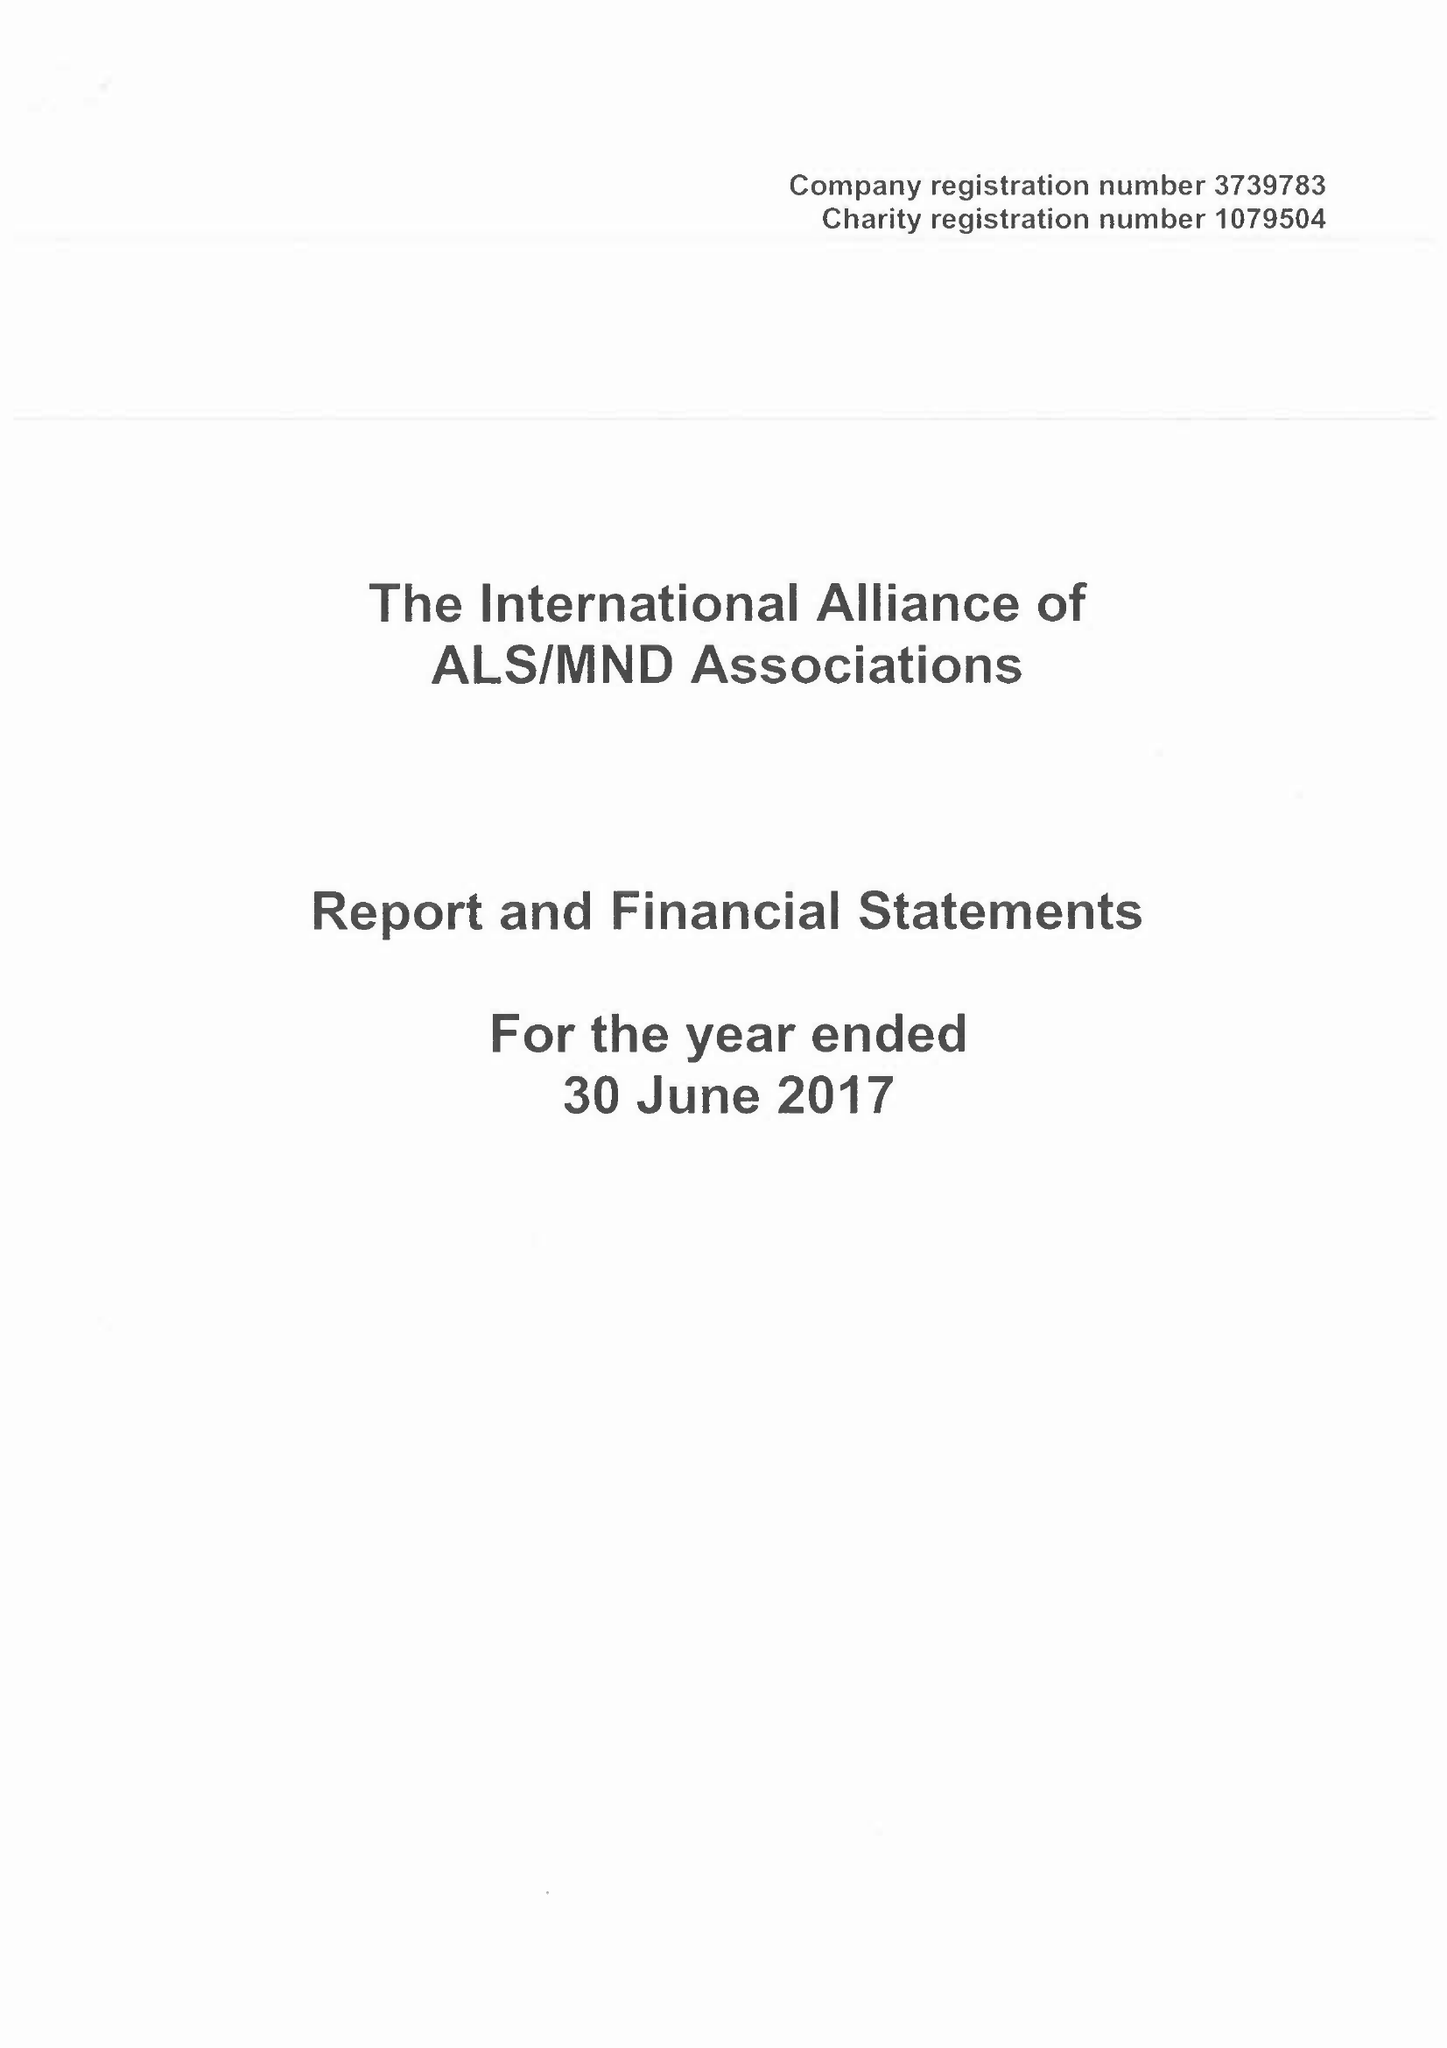What is the value for the report_date?
Answer the question using a single word or phrase. 2017-06-30 